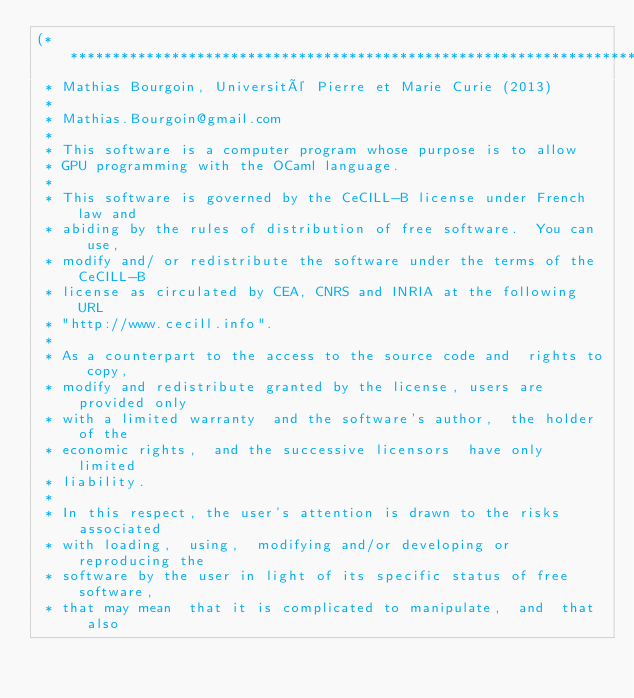<code> <loc_0><loc_0><loc_500><loc_500><_OCaml_>(******************************************************************************
 * Mathias Bourgoin, Université Pierre et Marie Curie (2013)
 *
 * Mathias.Bourgoin@gmail.com
 *
 * This software is a computer program whose purpose is to allow
 * GPU programming with the OCaml language.
 *
 * This software is governed by the CeCILL-B license under French law and
 * abiding by the rules of distribution of free software.  You can  use,
 * modify and/ or redistribute the software under the terms of the CeCILL-B
 * license as circulated by CEA, CNRS and INRIA at the following URL
 * "http://www.cecill.info".
 *
 * As a counterpart to the access to the source code and  rights to copy,
 * modify and redistribute granted by the license, users are provided only
 * with a limited warranty  and the software's author,  the holder of the
 * economic rights,  and the successive licensors  have only  limited
 * liability.
 *
 * In this respect, the user's attention is drawn to the risks associated
 * with loading,  using,  modifying and/or developing or reproducing the
 * software by the user in light of its specific status of free software,
 * that may mean  that it is complicated to manipulate,  and  that  also</code> 